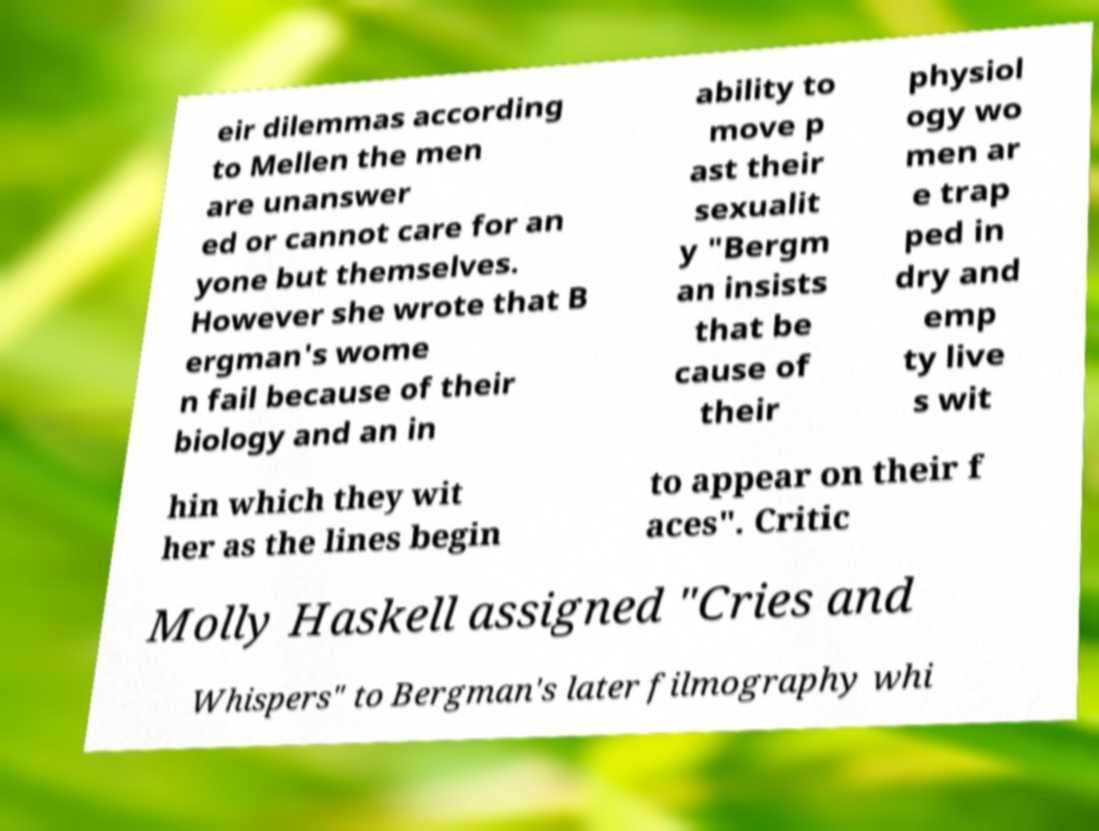For documentation purposes, I need the text within this image transcribed. Could you provide that? eir dilemmas according to Mellen the men are unanswer ed or cannot care for an yone but themselves. However she wrote that B ergman's wome n fail because of their biology and an in ability to move p ast their sexualit y "Bergm an insists that be cause of their physiol ogy wo men ar e trap ped in dry and emp ty live s wit hin which they wit her as the lines begin to appear on their f aces". Critic Molly Haskell assigned "Cries and Whispers" to Bergman's later filmography whi 